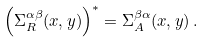Convert formula to latex. <formula><loc_0><loc_0><loc_500><loc_500>\left ( \Sigma _ { R } ^ { \alpha \beta } ( x , y ) \right ) ^ { * } = \Sigma _ { A } ^ { \beta \alpha } ( x , y ) \, .</formula> 